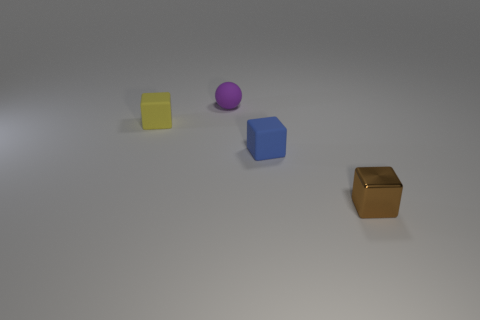Add 3 small objects. How many objects exist? 7 Subtract all balls. How many objects are left? 3 Subtract 0 brown spheres. How many objects are left? 4 Subtract all spheres. Subtract all tiny purple balls. How many objects are left? 2 Add 4 tiny yellow objects. How many tiny yellow objects are left? 5 Add 2 tiny red cubes. How many tiny red cubes exist? 2 